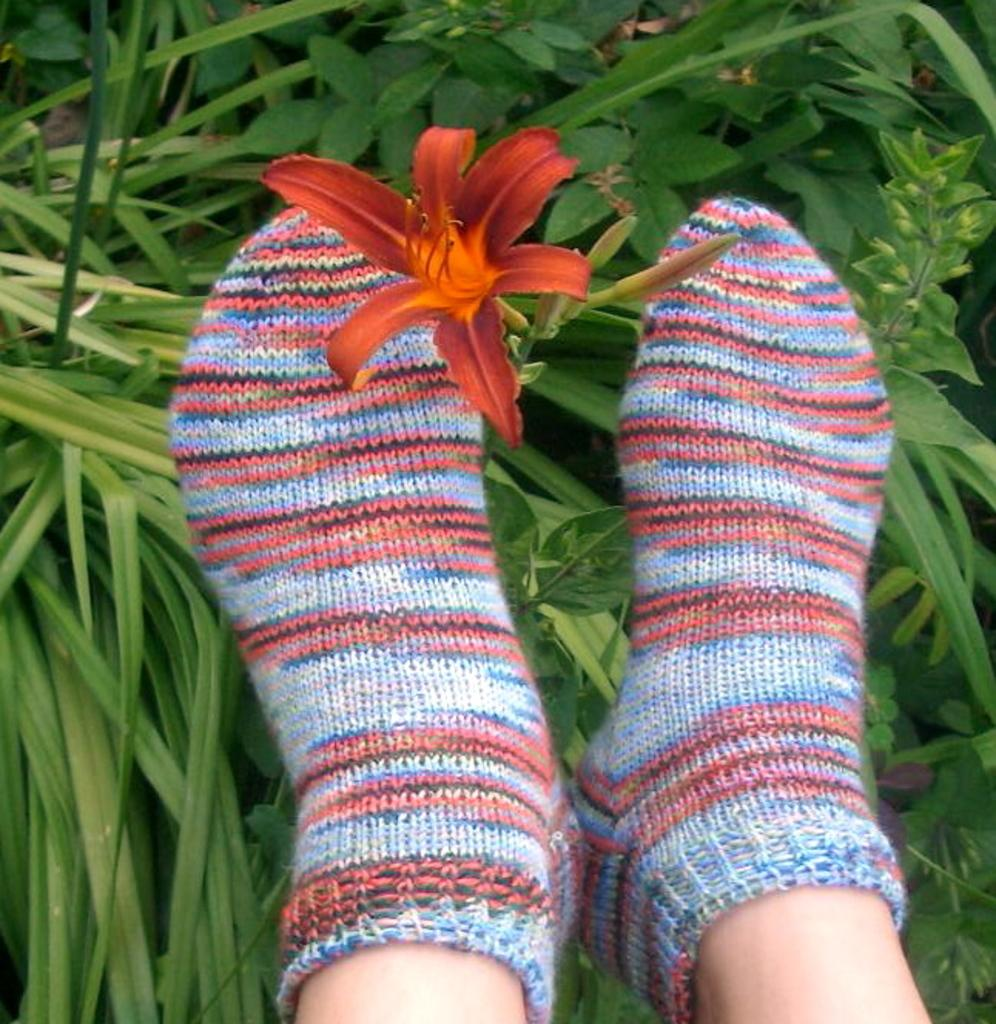What part of a person's body is visible in the image? There is a person's leg in the image. What type of clothing is the person's leg wearing? The person's leg is wearing woolen socks. What kind of flower can be seen in the image? There is a red color flower in the image. What can be seen in the background of the image? There are plants visible in the background of the image. Can you tell me how many ants are crawling on the person's leg in the image? There are no ants visible on the person's leg in the image. What type of agreement was reached between the person and the flower in the image? There is no indication of any agreement between the person and the flower in the image. 